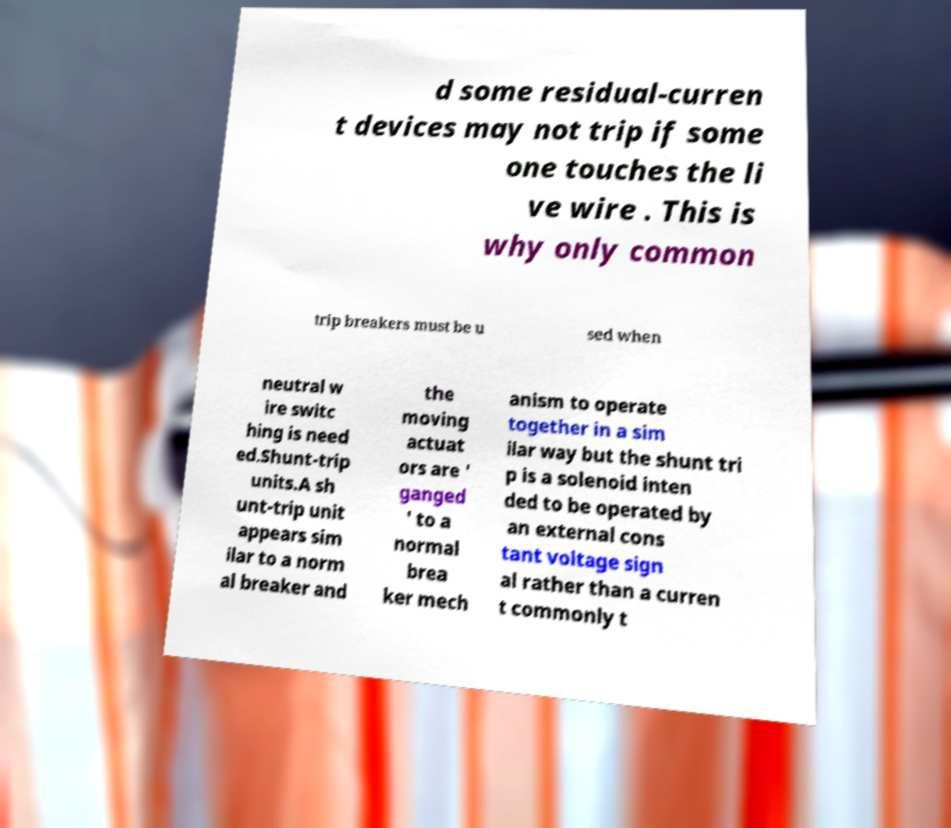Please identify and transcribe the text found in this image. d some residual-curren t devices may not trip if some one touches the li ve wire . This is why only common trip breakers must be u sed when neutral w ire switc hing is need ed.Shunt-trip units.A sh unt-trip unit appears sim ilar to a norm al breaker and the moving actuat ors are ' ganged ' to a normal brea ker mech anism to operate together in a sim ilar way but the shunt tri p is a solenoid inten ded to be operated by an external cons tant voltage sign al rather than a curren t commonly t 